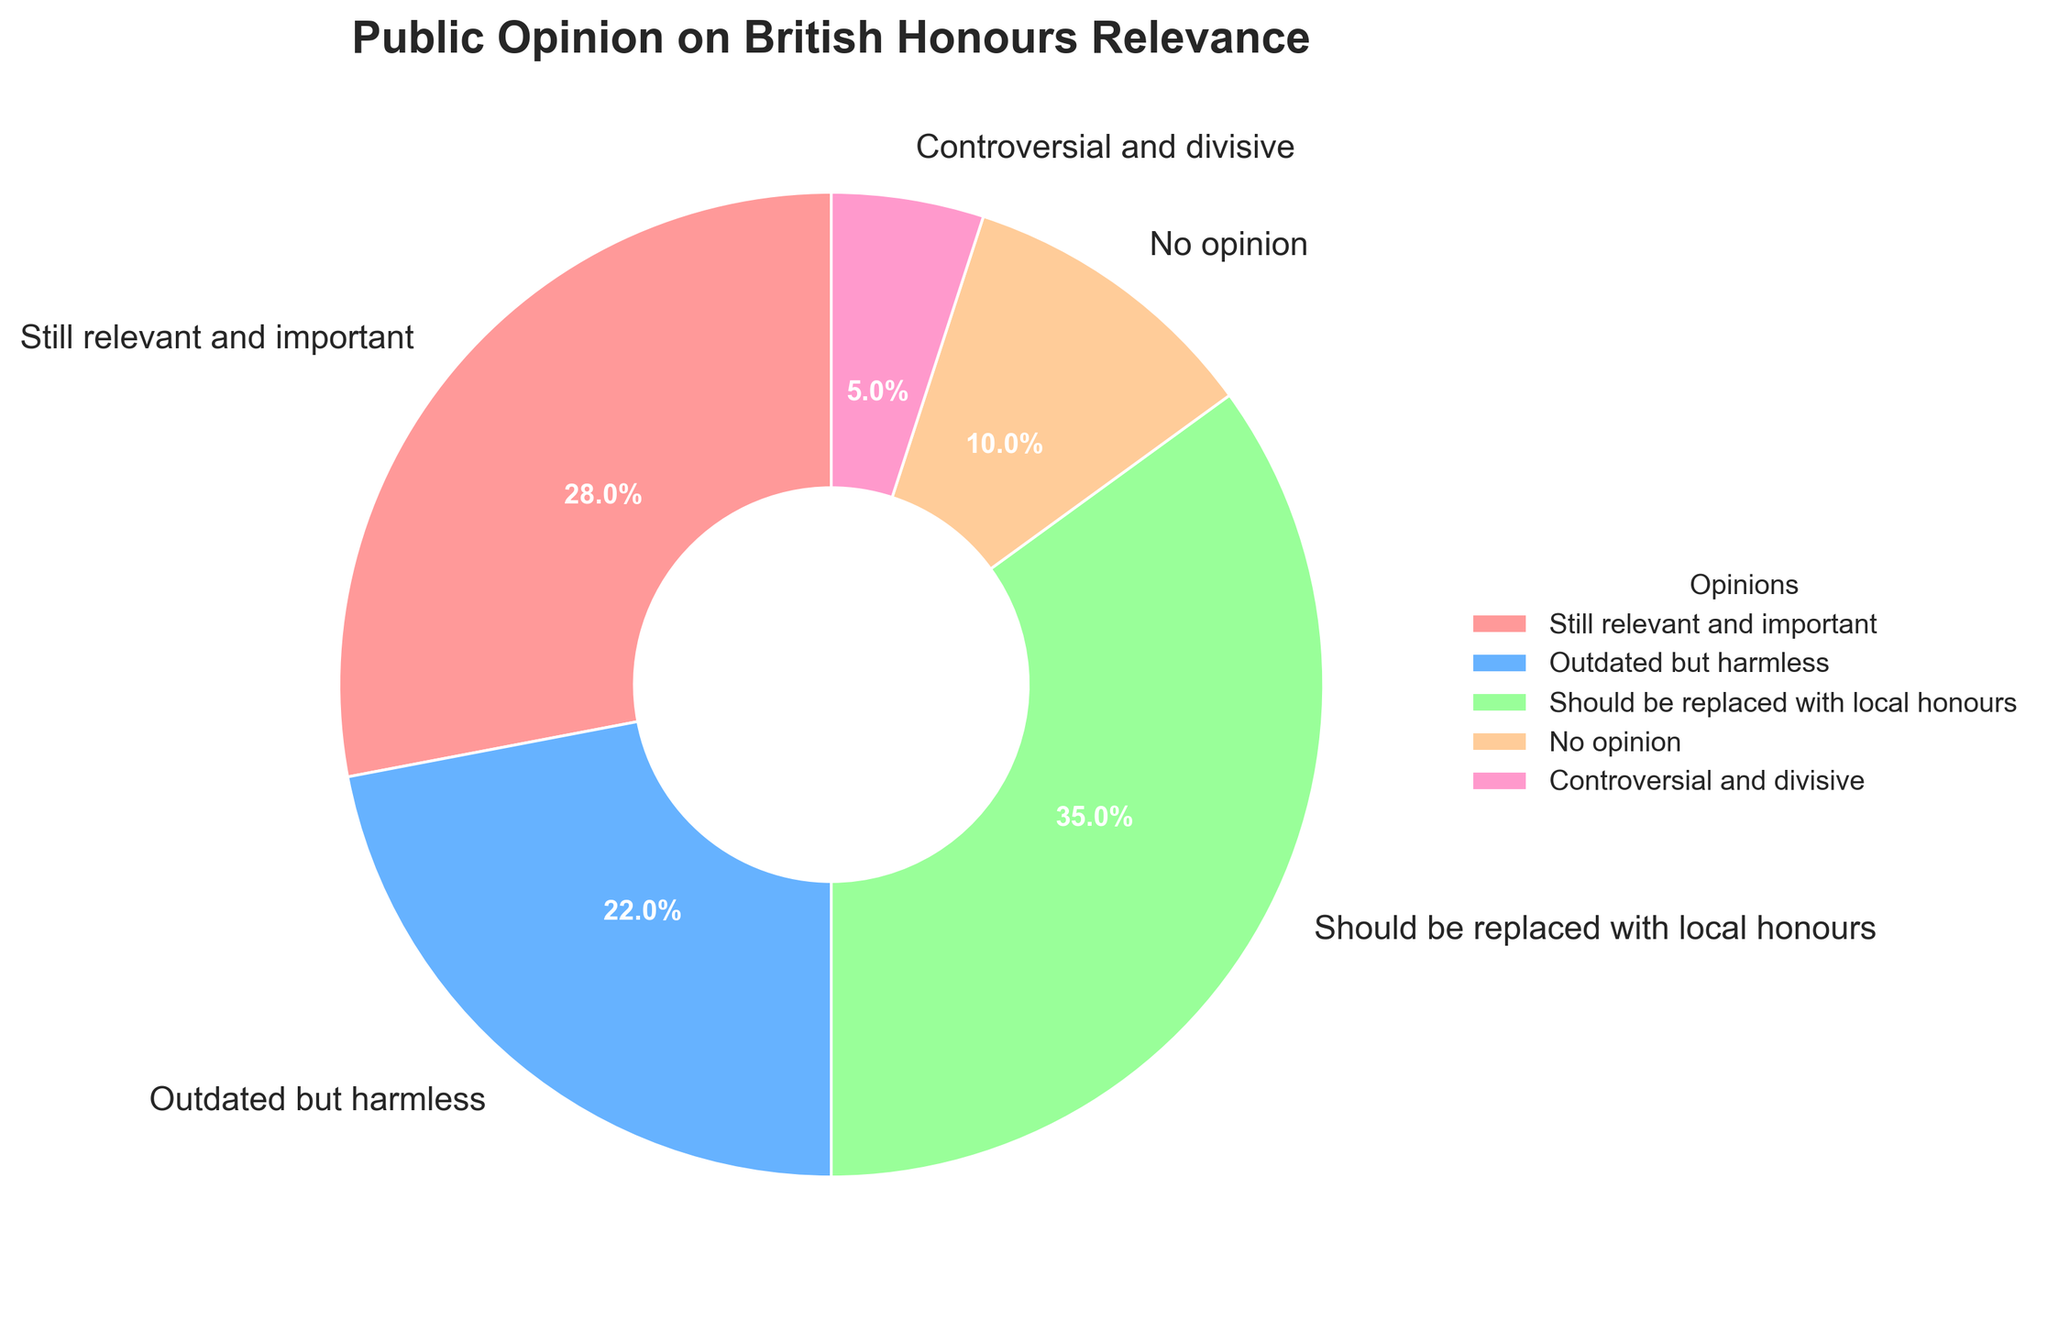What percentage of people believe British honours are outdated but harmless? Locate the slice of the pie chart labeled "Outdated but harmless" and check the accompanying percentage value.
Answer: 22% What is the total percentage of people who either have no opinion or find the honours controversial and divisive? Add the percentages of "No opinion" (10%) and "Controversial and divisive" (5%). The total is 10% + 5% = 15%.
Answer: 15% Which opinion category has the highest percentage? Identify the largest slice of the pie chart and refer to its label, which in this case is "Should be replaced with local honours" at 35%.
Answer: Should be replaced with local honours What is the difference in percentage between those who think the honours should be replaced with local honours and those who find them still relevant and important? Subtract the percentage of "Still relevant and important" (28%) from "Should be replaced with local honours" (35%). The difference is 35% - 28% = 7%.
Answer: 7% Which opinion is shared by the smallest percentage of people? Identify the smallest wedge in the pie chart, which corresponds to "Controversial and divisive" at 5%.
Answer: Controversial and divisive What is the combined percentage of people who think the honours are either still relevant and important or outdated but harmless? Add the percentages of "Still relevant and important" (28%) and "Outdated but harmless" (22%). The combined percentage is 28% + 22% = 50%.
Answer: 50% How does the percentage of those who have no opinion compare to those who find the honours controversial and divisive? Compare the wedge sizes for "No opinion" (10%) and "Controversial and divisive" (5%). 10% is twice as large as 5%.
Answer: Twice as large 